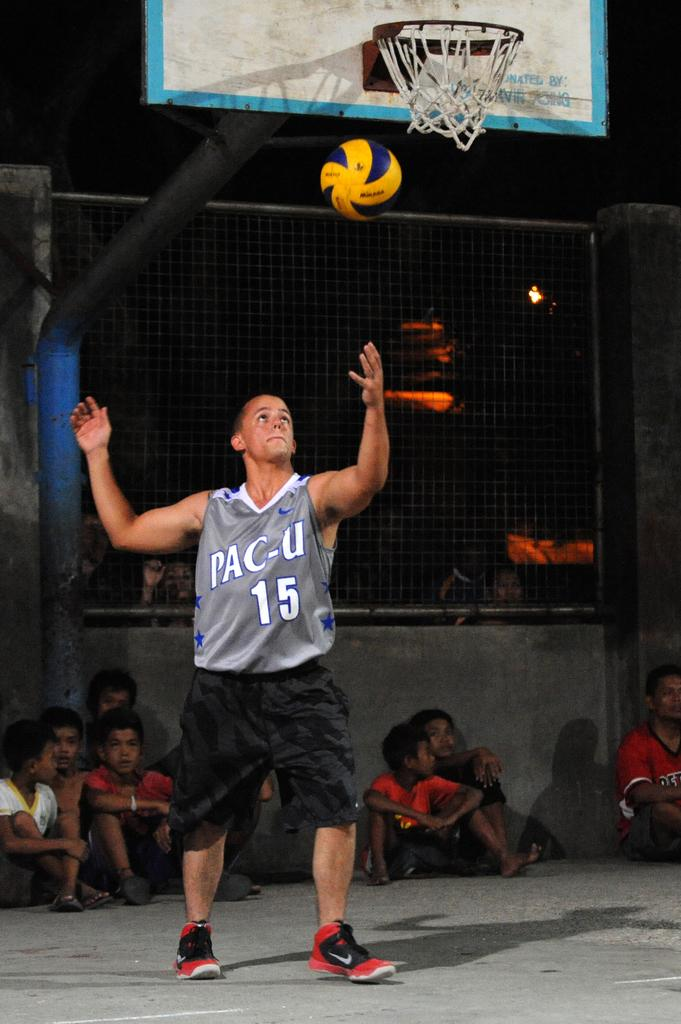<image>
Describe the image concisely. A man in a Pac-U jersey prepares to catch a ball. 